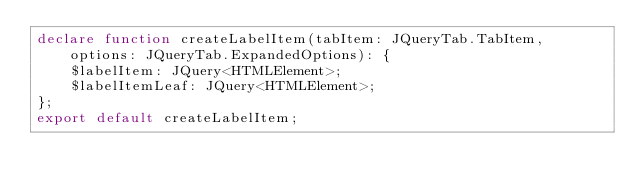<code> <loc_0><loc_0><loc_500><loc_500><_TypeScript_>declare function createLabelItem(tabItem: JQueryTab.TabItem, options: JQueryTab.ExpandedOptions): {
    $labelItem: JQuery<HTMLElement>;
    $labelItemLeaf: JQuery<HTMLElement>;
};
export default createLabelItem;
</code> 